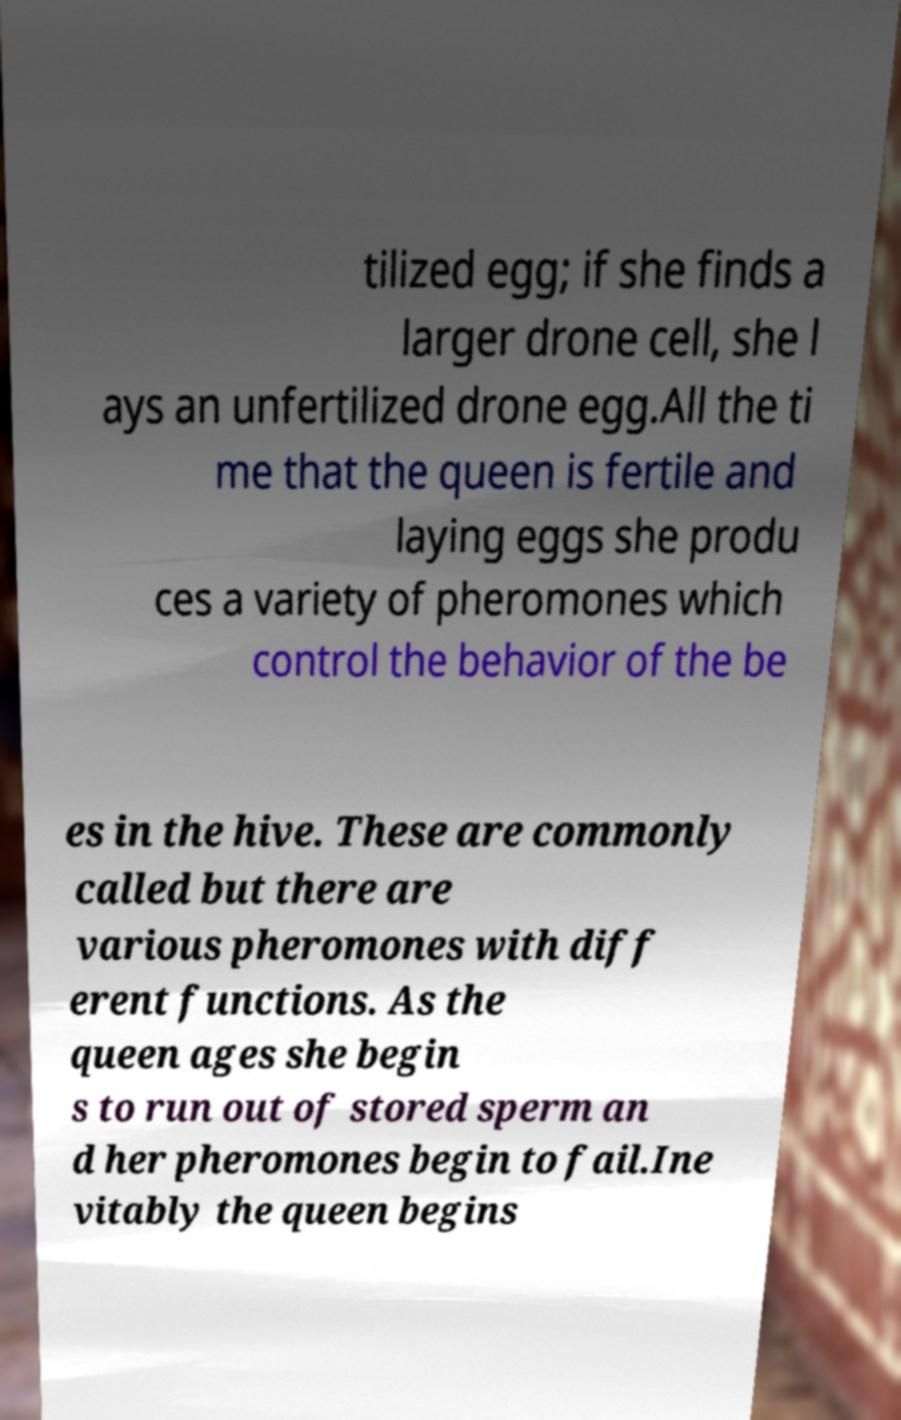What messages or text are displayed in this image? I need them in a readable, typed format. tilized egg; if she finds a larger drone cell, she l ays an unfertilized drone egg.All the ti me that the queen is fertile and laying eggs she produ ces a variety of pheromones which control the behavior of the be es in the hive. These are commonly called but there are various pheromones with diff erent functions. As the queen ages she begin s to run out of stored sperm an d her pheromones begin to fail.Ine vitably the queen begins 